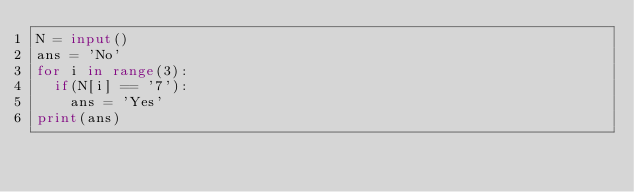Convert code to text. <code><loc_0><loc_0><loc_500><loc_500><_Python_>N = input()
ans = 'No'
for i in range(3):
  if(N[i] == '7'):
    ans = 'Yes'
print(ans)</code> 